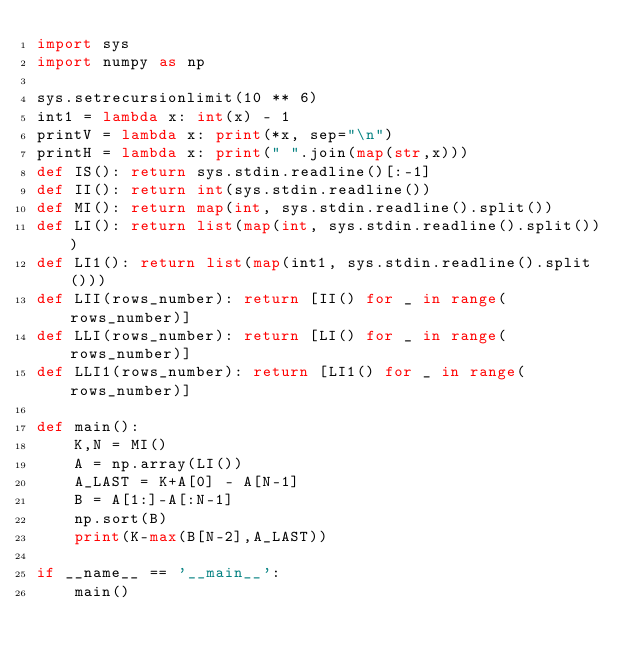<code> <loc_0><loc_0><loc_500><loc_500><_Python_>import sys
import numpy as np

sys.setrecursionlimit(10 ** 6)
int1 = lambda x: int(x) - 1
printV = lambda x: print(*x, sep="\n")
printH = lambda x: print(" ".join(map(str,x)))
def IS(): return sys.stdin.readline()[:-1]
def II(): return int(sys.stdin.readline())
def MI(): return map(int, sys.stdin.readline().split())
def LI(): return list(map(int, sys.stdin.readline().split()))
def LI1(): return list(map(int1, sys.stdin.readline().split()))
def LII(rows_number): return [II() for _ in range(rows_number)]
def LLI(rows_number): return [LI() for _ in range(rows_number)]
def LLI1(rows_number): return [LI1() for _ in range(rows_number)]

def main():
	K,N = MI()
	A = np.array(LI())
	A_LAST = K+A[0] - A[N-1]
	B = A[1:]-A[:N-1]
	np.sort(B)
	print(K-max(B[N-2],A_LAST))

if __name__ == '__main__':
	main()</code> 